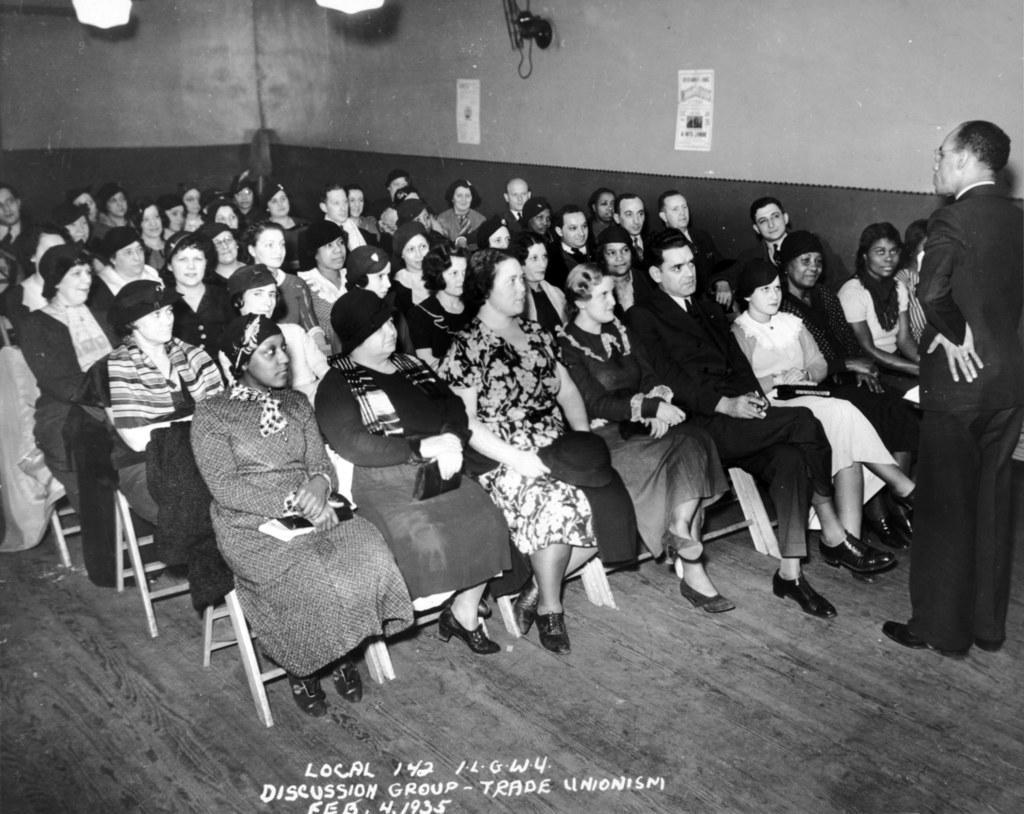Please provide a concise description of this image. In this image i can see a group of people sitting on a chair at front there is a man standing at the back ground i can see a wall, a paper at the top there is a light. 